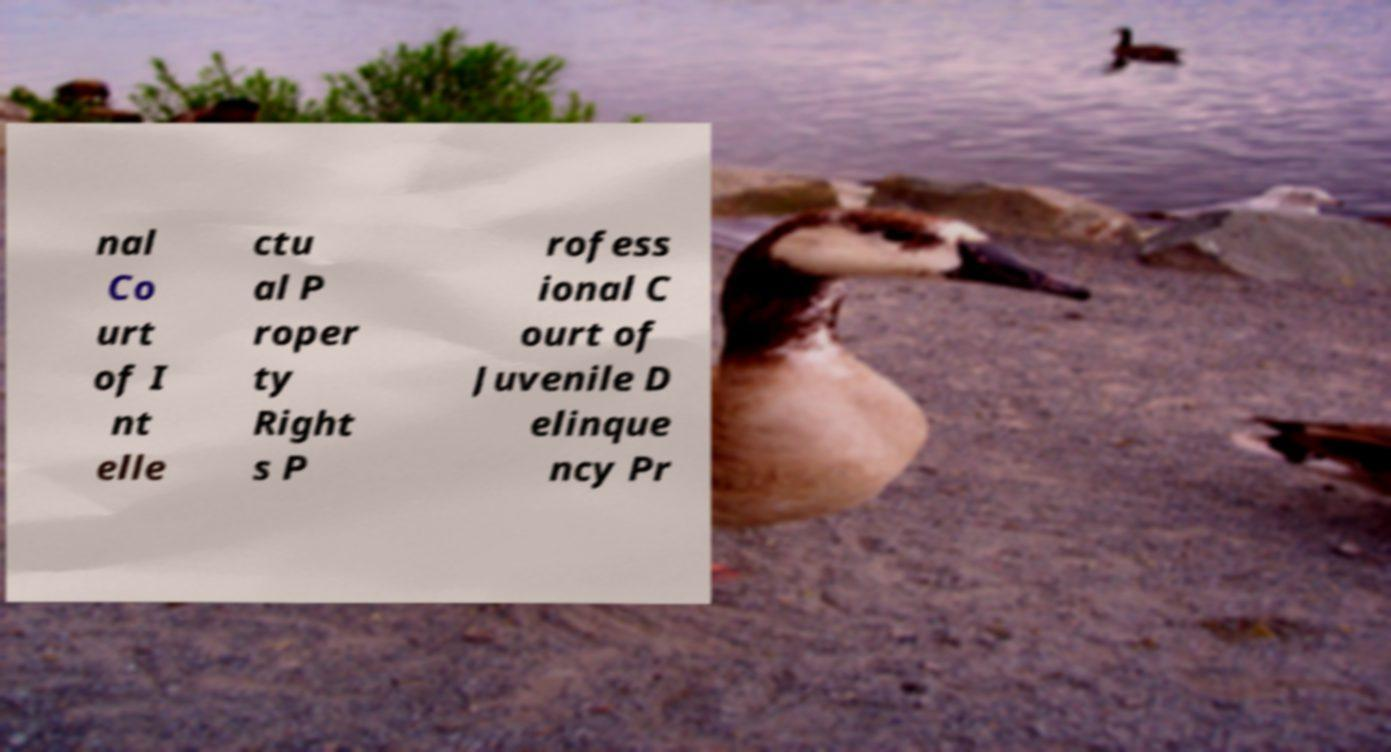Could you assist in decoding the text presented in this image and type it out clearly? nal Co urt of I nt elle ctu al P roper ty Right s P rofess ional C ourt of Juvenile D elinque ncy Pr 